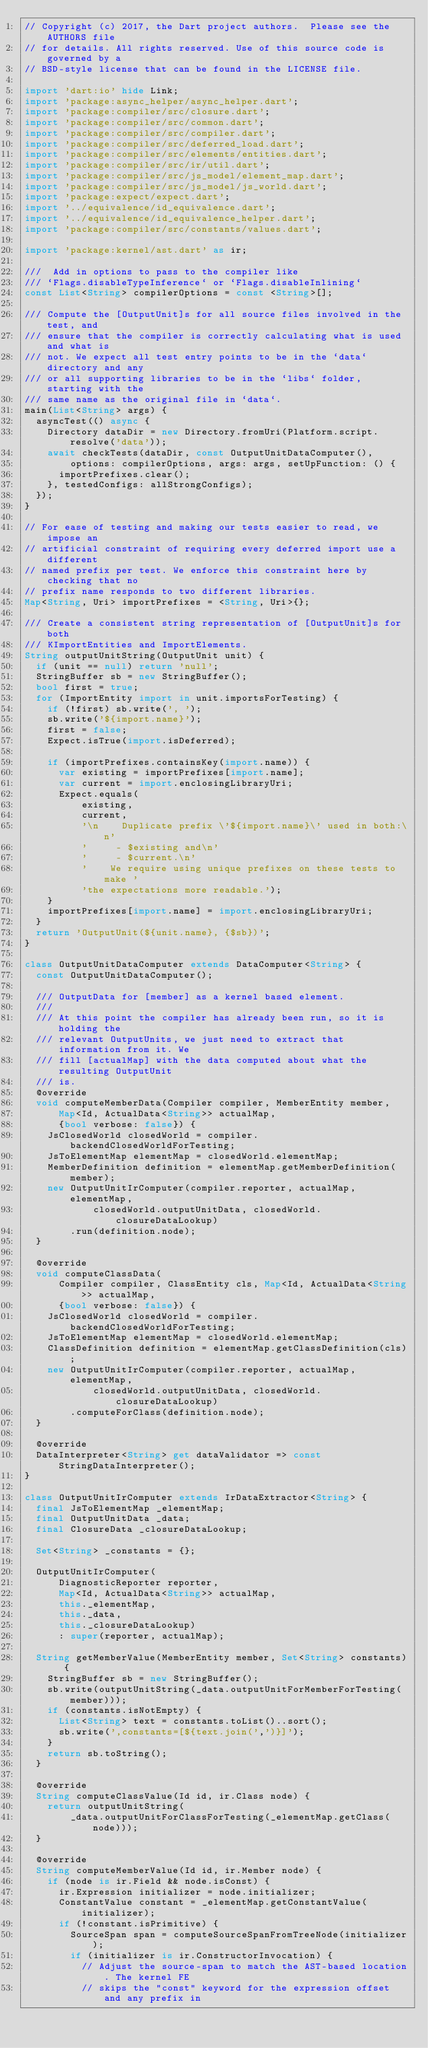<code> <loc_0><loc_0><loc_500><loc_500><_Dart_>// Copyright (c) 2017, the Dart project authors.  Please see the AUTHORS file
// for details. All rights reserved. Use of this source code is governed by a
// BSD-style license that can be found in the LICENSE file.

import 'dart:io' hide Link;
import 'package:async_helper/async_helper.dart';
import 'package:compiler/src/closure.dart';
import 'package:compiler/src/common.dart';
import 'package:compiler/src/compiler.dart';
import 'package:compiler/src/deferred_load.dart';
import 'package:compiler/src/elements/entities.dart';
import 'package:compiler/src/ir/util.dart';
import 'package:compiler/src/js_model/element_map.dart';
import 'package:compiler/src/js_model/js_world.dart';
import 'package:expect/expect.dart';
import '../equivalence/id_equivalence.dart';
import '../equivalence/id_equivalence_helper.dart';
import 'package:compiler/src/constants/values.dart';

import 'package:kernel/ast.dart' as ir;

///  Add in options to pass to the compiler like
/// `Flags.disableTypeInference` or `Flags.disableInlining`
const List<String> compilerOptions = const <String>[];

/// Compute the [OutputUnit]s for all source files involved in the test, and
/// ensure that the compiler is correctly calculating what is used and what is
/// not. We expect all test entry points to be in the `data` directory and any
/// or all supporting libraries to be in the `libs` folder, starting with the
/// same name as the original file in `data`.
main(List<String> args) {
  asyncTest(() async {
    Directory dataDir = new Directory.fromUri(Platform.script.resolve('data'));
    await checkTests(dataDir, const OutputUnitDataComputer(),
        options: compilerOptions, args: args, setUpFunction: () {
      importPrefixes.clear();
    }, testedConfigs: allStrongConfigs);
  });
}

// For ease of testing and making our tests easier to read, we impose an
// artificial constraint of requiring every deferred import use a different
// named prefix per test. We enforce this constraint here by checking that no
// prefix name responds to two different libraries.
Map<String, Uri> importPrefixes = <String, Uri>{};

/// Create a consistent string representation of [OutputUnit]s for both
/// KImportEntities and ImportElements.
String outputUnitString(OutputUnit unit) {
  if (unit == null) return 'null';
  StringBuffer sb = new StringBuffer();
  bool first = true;
  for (ImportEntity import in unit.importsForTesting) {
    if (!first) sb.write(', ');
    sb.write('${import.name}');
    first = false;
    Expect.isTrue(import.isDeferred);

    if (importPrefixes.containsKey(import.name)) {
      var existing = importPrefixes[import.name];
      var current = import.enclosingLibraryUri;
      Expect.equals(
          existing,
          current,
          '\n    Duplicate prefix \'${import.name}\' used in both:\n'
          '     - $existing and\n'
          '     - $current.\n'
          '    We require using unique prefixes on these tests to make '
          'the expectations more readable.');
    }
    importPrefixes[import.name] = import.enclosingLibraryUri;
  }
  return 'OutputUnit(${unit.name}, {$sb})';
}

class OutputUnitDataComputer extends DataComputer<String> {
  const OutputUnitDataComputer();

  /// OutputData for [member] as a kernel based element.
  ///
  /// At this point the compiler has already been run, so it is holding the
  /// relevant OutputUnits, we just need to extract that information from it. We
  /// fill [actualMap] with the data computed about what the resulting OutputUnit
  /// is.
  @override
  void computeMemberData(Compiler compiler, MemberEntity member,
      Map<Id, ActualData<String>> actualMap,
      {bool verbose: false}) {
    JsClosedWorld closedWorld = compiler.backendClosedWorldForTesting;
    JsToElementMap elementMap = closedWorld.elementMap;
    MemberDefinition definition = elementMap.getMemberDefinition(member);
    new OutputUnitIrComputer(compiler.reporter, actualMap, elementMap,
            closedWorld.outputUnitData, closedWorld.closureDataLookup)
        .run(definition.node);
  }

  @override
  void computeClassData(
      Compiler compiler, ClassEntity cls, Map<Id, ActualData<String>> actualMap,
      {bool verbose: false}) {
    JsClosedWorld closedWorld = compiler.backendClosedWorldForTesting;
    JsToElementMap elementMap = closedWorld.elementMap;
    ClassDefinition definition = elementMap.getClassDefinition(cls);
    new OutputUnitIrComputer(compiler.reporter, actualMap, elementMap,
            closedWorld.outputUnitData, closedWorld.closureDataLookup)
        .computeForClass(definition.node);
  }

  @override
  DataInterpreter<String> get dataValidator => const StringDataInterpreter();
}

class OutputUnitIrComputer extends IrDataExtractor<String> {
  final JsToElementMap _elementMap;
  final OutputUnitData _data;
  final ClosureData _closureDataLookup;

  Set<String> _constants = {};

  OutputUnitIrComputer(
      DiagnosticReporter reporter,
      Map<Id, ActualData<String>> actualMap,
      this._elementMap,
      this._data,
      this._closureDataLookup)
      : super(reporter, actualMap);

  String getMemberValue(MemberEntity member, Set<String> constants) {
    StringBuffer sb = new StringBuffer();
    sb.write(outputUnitString(_data.outputUnitForMemberForTesting(member)));
    if (constants.isNotEmpty) {
      List<String> text = constants.toList()..sort();
      sb.write(',constants=[${text.join(',')}]');
    }
    return sb.toString();
  }

  @override
  String computeClassValue(Id id, ir.Class node) {
    return outputUnitString(
        _data.outputUnitForClassForTesting(_elementMap.getClass(node)));
  }

  @override
  String computeMemberValue(Id id, ir.Member node) {
    if (node is ir.Field && node.isConst) {
      ir.Expression initializer = node.initializer;
      ConstantValue constant = _elementMap.getConstantValue(initializer);
      if (!constant.isPrimitive) {
        SourceSpan span = computeSourceSpanFromTreeNode(initializer);
        if (initializer is ir.ConstructorInvocation) {
          // Adjust the source-span to match the AST-based location. The kernel FE
          // skips the "const" keyword for the expression offset and any prefix in</code> 